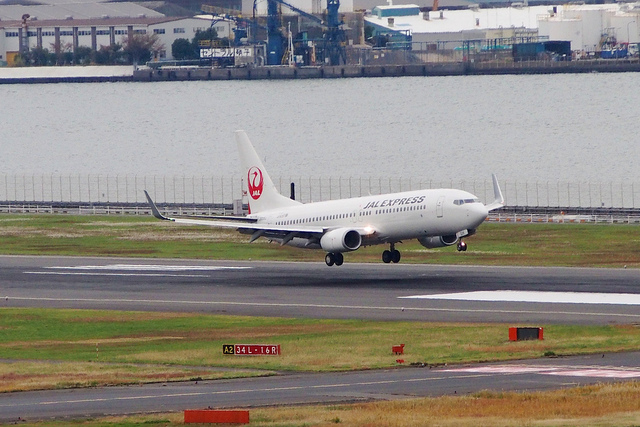Read all the text in this image. 16 L A2 JAL EXPRESS 